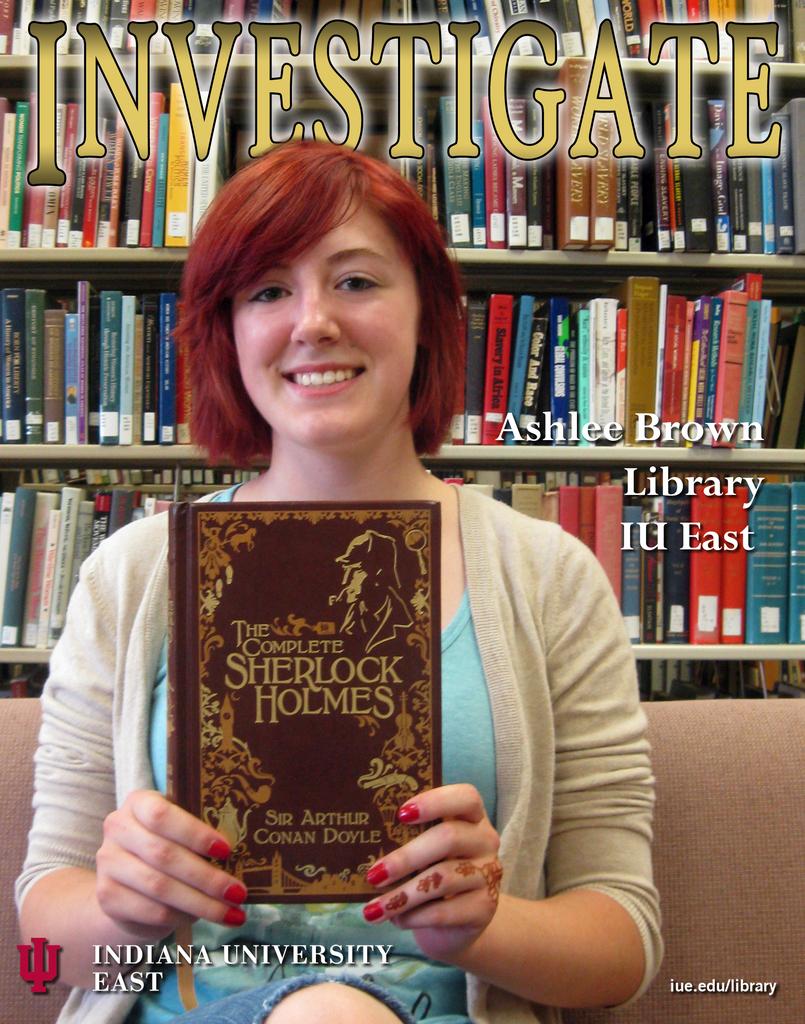What book is ashlee holding up?
Keep it short and to the point. The complete sherlock holmes. Who is the author of this book being shown?
Make the answer very short. Sir arthur conan doyle. 